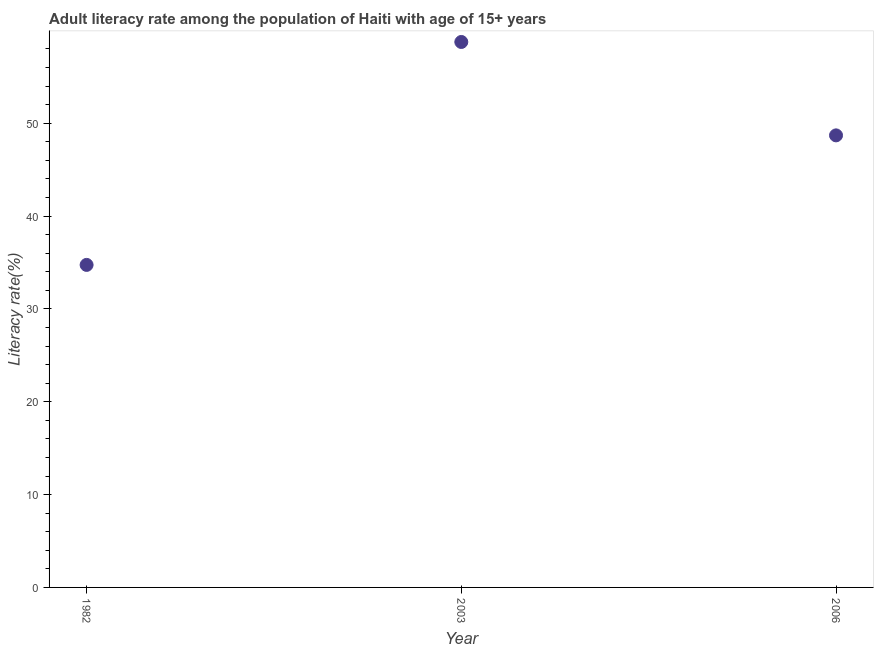What is the adult literacy rate in 2006?
Offer a terse response. 48.69. Across all years, what is the maximum adult literacy rate?
Offer a terse response. 58.74. Across all years, what is the minimum adult literacy rate?
Provide a short and direct response. 34.73. What is the sum of the adult literacy rate?
Provide a succinct answer. 142.16. What is the difference between the adult literacy rate in 1982 and 2003?
Offer a terse response. -24.01. What is the average adult literacy rate per year?
Your response must be concise. 47.39. What is the median adult literacy rate?
Provide a short and direct response. 48.69. In how many years, is the adult literacy rate greater than 14 %?
Give a very brief answer. 3. What is the ratio of the adult literacy rate in 1982 to that in 2003?
Your answer should be compact. 0.59. Is the adult literacy rate in 1982 less than that in 2003?
Provide a short and direct response. Yes. What is the difference between the highest and the second highest adult literacy rate?
Provide a short and direct response. 10.06. What is the difference between the highest and the lowest adult literacy rate?
Ensure brevity in your answer.  24.01. Does the adult literacy rate monotonically increase over the years?
Provide a short and direct response. No. How many years are there in the graph?
Keep it short and to the point. 3. What is the difference between two consecutive major ticks on the Y-axis?
Offer a terse response. 10. Are the values on the major ticks of Y-axis written in scientific E-notation?
Keep it short and to the point. No. Does the graph contain grids?
Make the answer very short. No. What is the title of the graph?
Keep it short and to the point. Adult literacy rate among the population of Haiti with age of 15+ years. What is the label or title of the X-axis?
Provide a succinct answer. Year. What is the label or title of the Y-axis?
Keep it short and to the point. Literacy rate(%). What is the Literacy rate(%) in 1982?
Give a very brief answer. 34.73. What is the Literacy rate(%) in 2003?
Offer a very short reply. 58.74. What is the Literacy rate(%) in 2006?
Provide a short and direct response. 48.69. What is the difference between the Literacy rate(%) in 1982 and 2003?
Give a very brief answer. -24.01. What is the difference between the Literacy rate(%) in 1982 and 2006?
Ensure brevity in your answer.  -13.95. What is the difference between the Literacy rate(%) in 2003 and 2006?
Your response must be concise. 10.06. What is the ratio of the Literacy rate(%) in 1982 to that in 2003?
Provide a succinct answer. 0.59. What is the ratio of the Literacy rate(%) in 1982 to that in 2006?
Provide a succinct answer. 0.71. What is the ratio of the Literacy rate(%) in 2003 to that in 2006?
Your response must be concise. 1.21. 